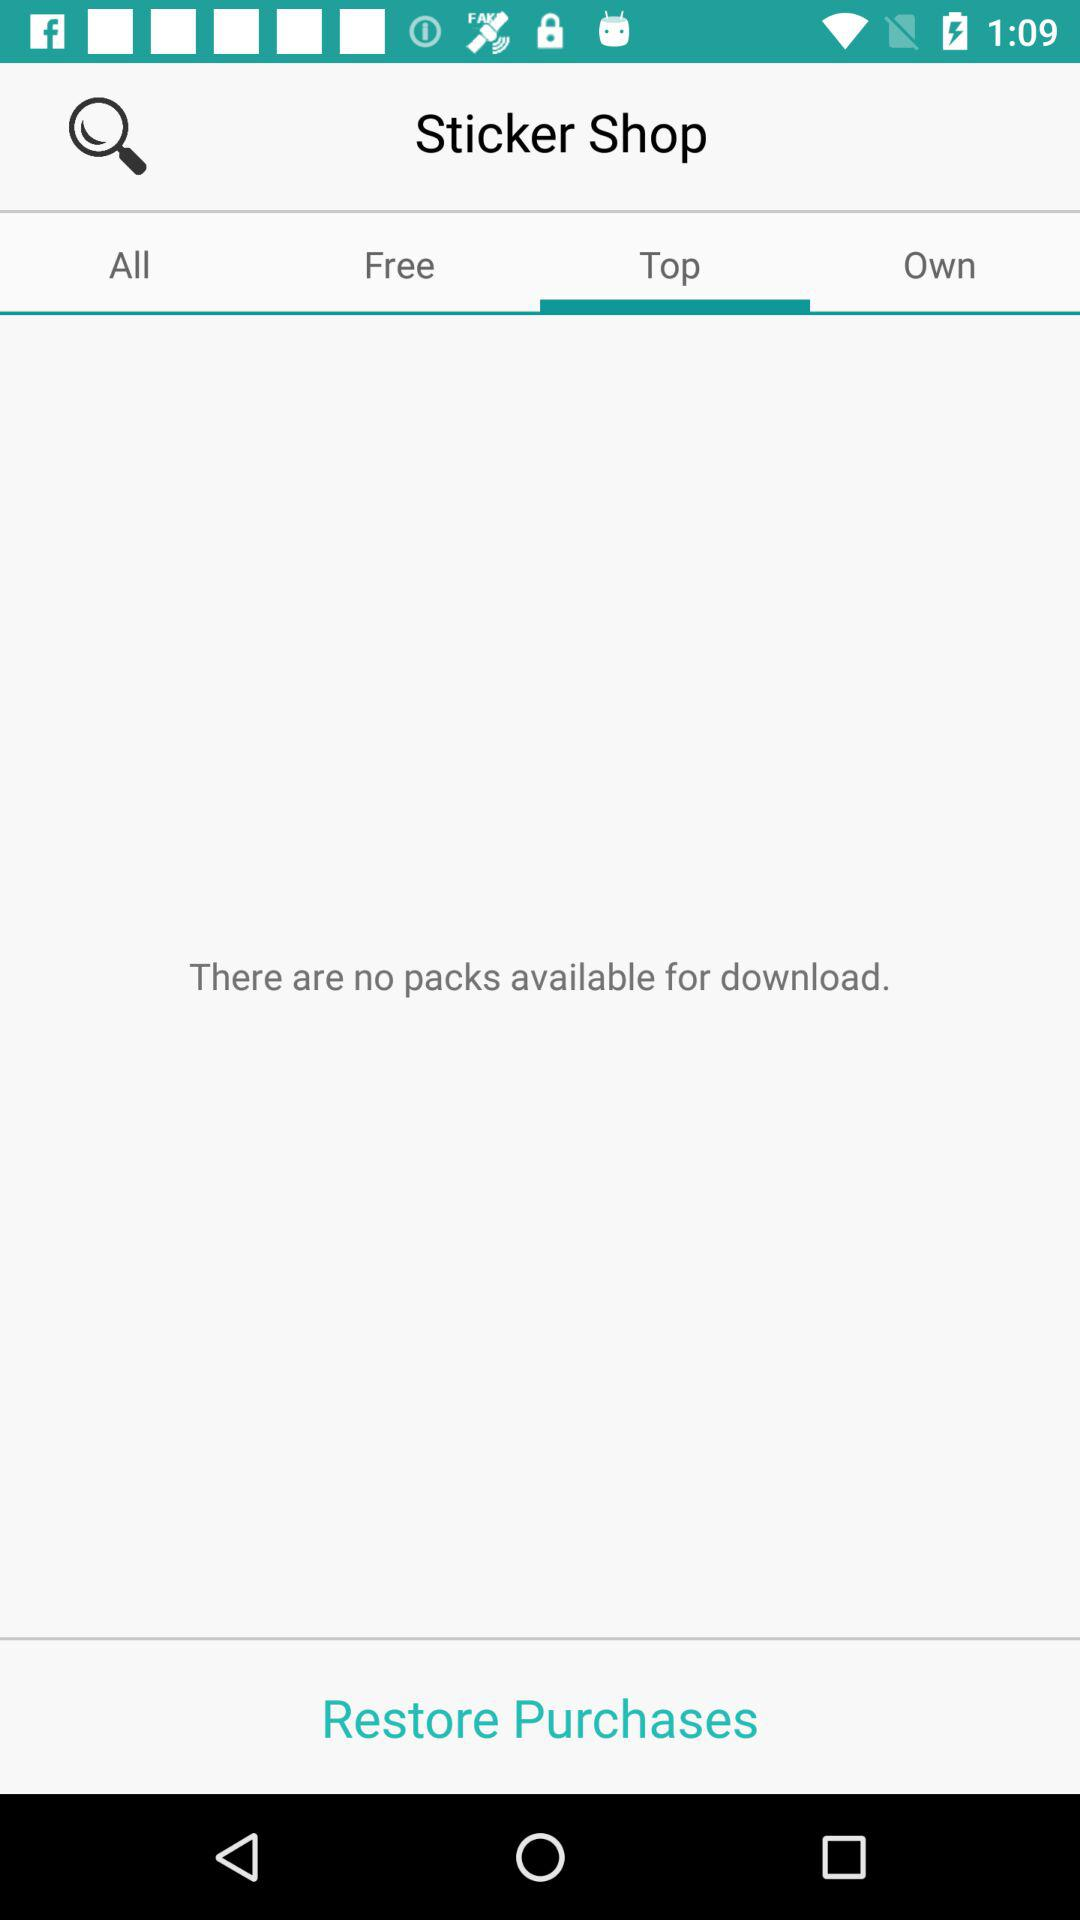Which tab is selected right now? The selected tab is "Top". 